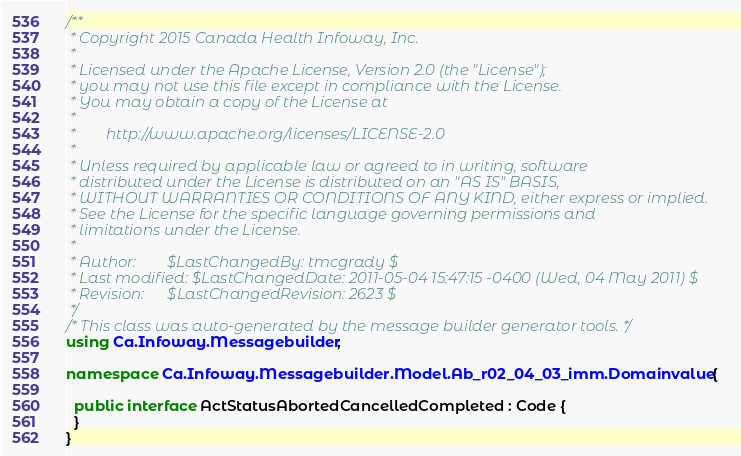<code> <loc_0><loc_0><loc_500><loc_500><_C#_>/**
 * Copyright 2015 Canada Health Infoway, Inc.
 *
 * Licensed under the Apache License, Version 2.0 (the "License");
 * you may not use this file except in compliance with the License.
 * You may obtain a copy of the License at
 *
 *        http://www.apache.org/licenses/LICENSE-2.0
 *
 * Unless required by applicable law or agreed to in writing, software
 * distributed under the License is distributed on an "AS IS" BASIS,
 * WITHOUT WARRANTIES OR CONDITIONS OF ANY KIND, either express or implied.
 * See the License for the specific language governing permissions and
 * limitations under the License.
 *
 * Author:        $LastChangedBy: tmcgrady $
 * Last modified: $LastChangedDate: 2011-05-04 15:47:15 -0400 (Wed, 04 May 2011) $
 * Revision:      $LastChangedRevision: 2623 $
 */
/* This class was auto-generated by the message builder generator tools. */
using Ca.Infoway.Messagebuilder;

namespace Ca.Infoway.Messagebuilder.Model.Ab_r02_04_03_imm.Domainvalue {

  public interface ActStatusAbortedCancelledCompleted : Code {
  }
}
</code> 